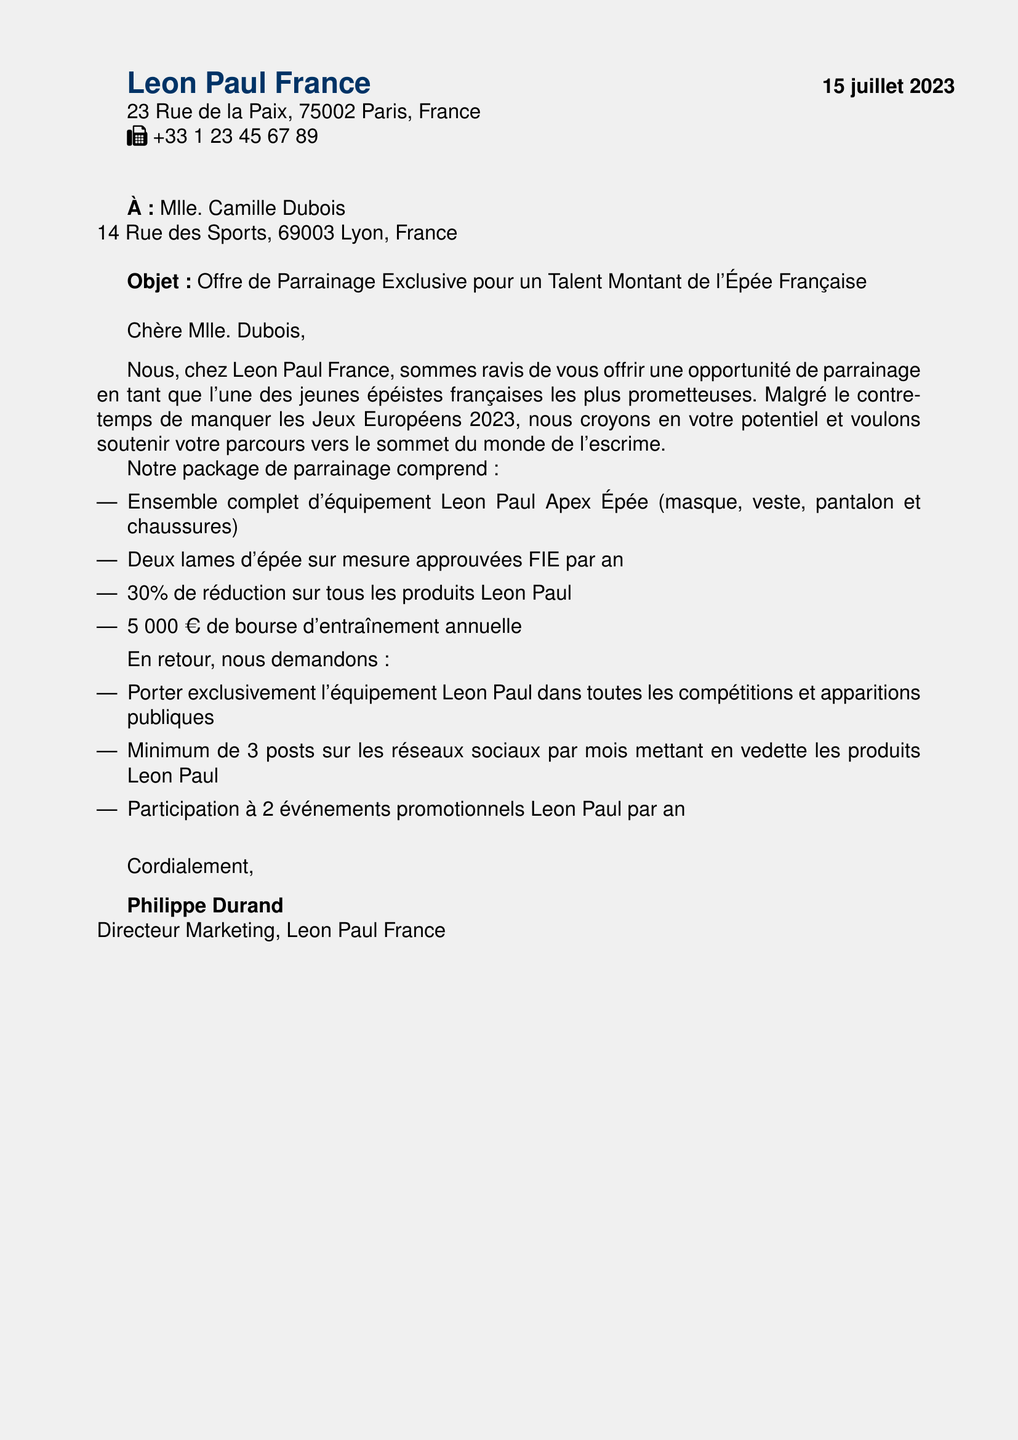Quelle est la date de l'offre de parrainage? La date de l'offre est indiquée en haut du document.
Answer: 15 juillet 2023 Quel est le montant de la bourse d'entraînement annuelle? Le montant de la bourse est mentionné dans le package de parrainage.
Answer: 5 000 € Qui est le responsable de l'offre de parrainage? Le responsable est mentionné à la fin de la lettre.
Answer: Philippe Durand Quels équipements sont inclus dans le package? Les équipements inclus sont listés dans le document.
Answer: Ensemble complet d'équipement Leon Paul Apex Épée Combien de publications sur les réseaux sociaux sont demandées par mois? Le nombre de publications requises est précisé dans les demandes de l'offre.
Answer: Minimum de 3 Quel type d'équipement est fourni en deux lames par an? Le type d'équipement est spécifié dans les détails du parrainage.
Answer: Lames d'épée sur mesure Quels événements doit-elle participer chaque année? Les événements à participer sont précisés dans le package de parrainage.
Answer: 2 événements promotionnels Pourquoi a-t-on proposé ce parrainage, selon le document? La raison est expliqué dans le premier paragraphe de la lettre.
Answer: Croire en votre potentiel 